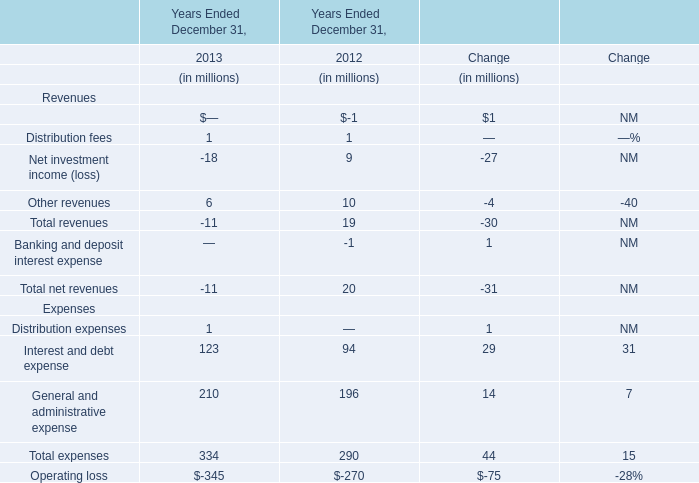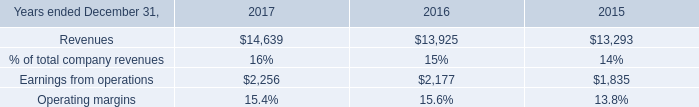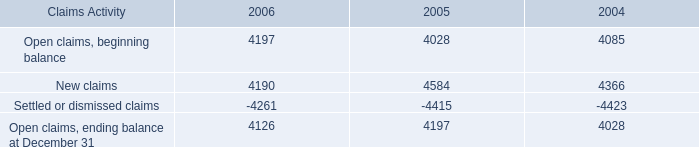What's the total amount of expenses without those expenses smaller than 100 in 2013? (in million) 
Computations: (123 + 210)
Answer: 333.0. 